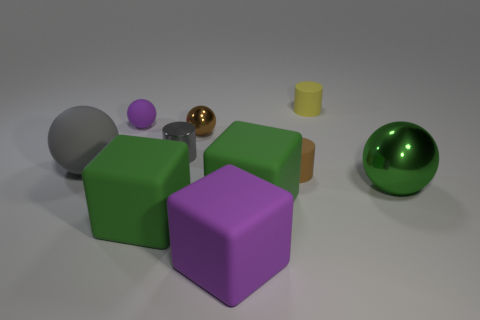Subtract 1 spheres. How many spheres are left? 3 Subtract all cylinders. How many objects are left? 7 Add 3 big rubber spheres. How many big rubber spheres exist? 4 Subtract 1 brown cylinders. How many objects are left? 9 Subtract all small cylinders. Subtract all spheres. How many objects are left? 3 Add 3 gray rubber objects. How many gray rubber objects are left? 4 